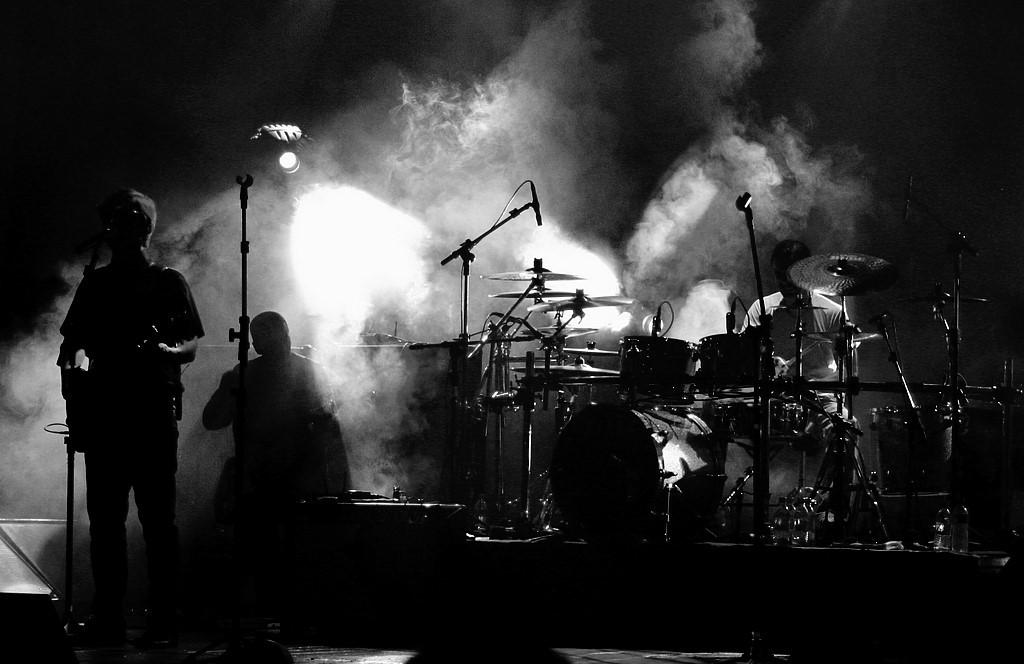What are the persons in the image doing? The persons in the image are playing musical instruments. What specific musical instruments can be seen in the image? The musical instruments include drums and guitar. What are the microphones used for in the image? The microphones (mics) are in front of the musicians, likely for amplifying their sound. How would you describe the lighting in the image? The background of the image is dark. What type of seed is being planted in the image? There is no seed or planting activity present in the image. How many flies can be seen buzzing around the musicians in the image? There are no flies visible in the image. 